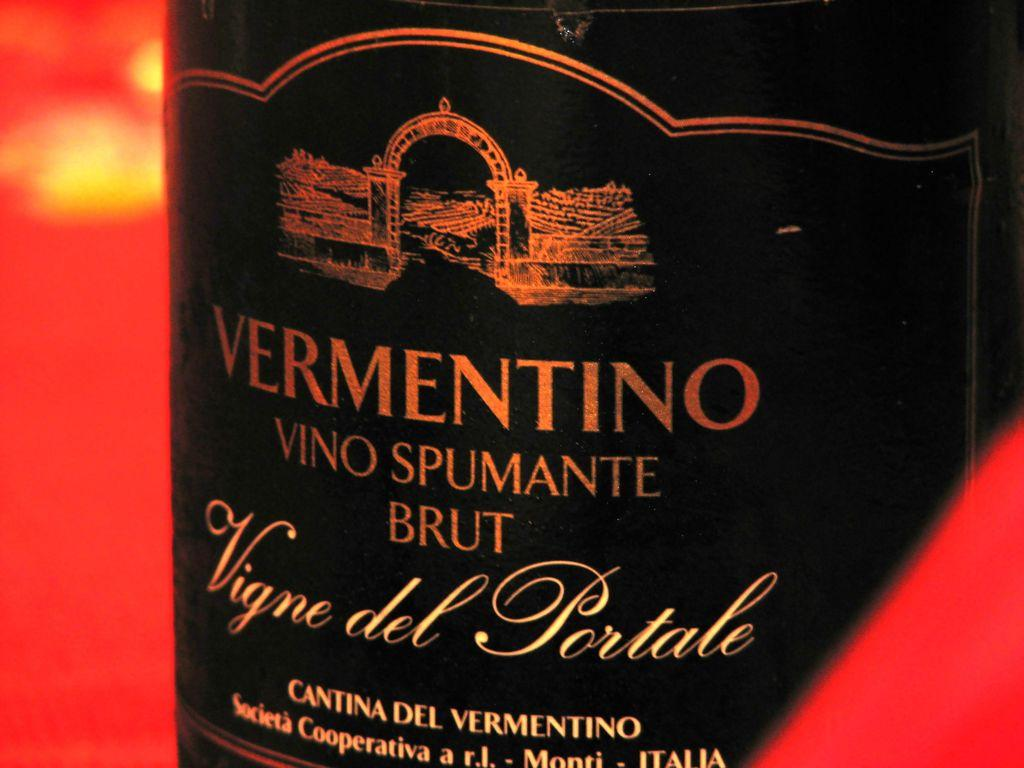Provide a one-sentence caption for the provided image. The label for VERMENTINO VINO SPUMANTE BRUT Vigne del Portale is shown. 